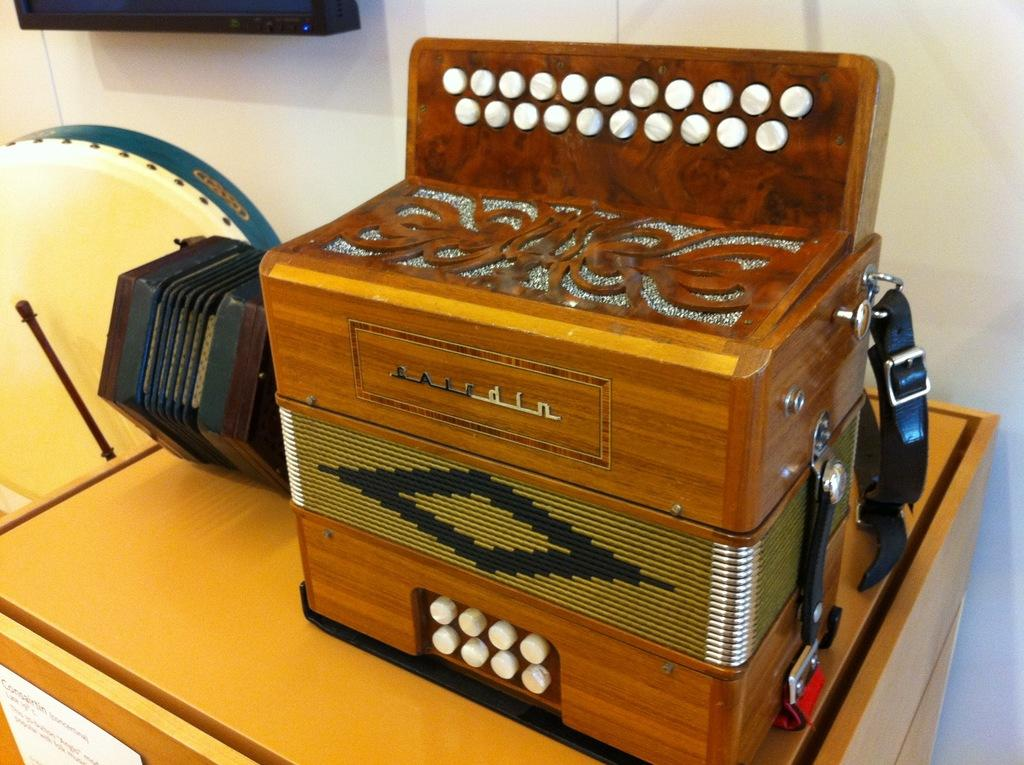What is present on the table in the image? There are objects on the table in the image. Can you describe the paper note in front of the table? There is a paper note with text on it in front of the table. What can be seen on the wall behind the table? There is a monitor on the wall behind the table. Can you tell me how many cans are visible on the table in the image? There is no mention of cans in the provided facts, so we cannot determine if any cans are visible in the image. What type of horn is present on the table in the image? There is no mention of a horn in the provided facts, so we cannot determine if any horn is present in the image. 